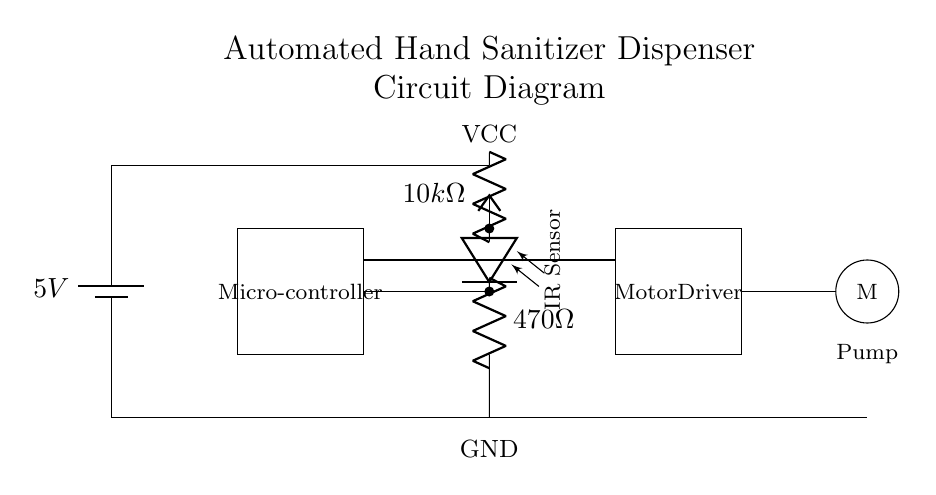What is the voltage supplied in this circuit? The circuit diagram shows a battery marked as 5V connected at the top of the circuit. This indicates that the total voltage supplied to the circuit is 5V.
Answer: 5V What is the purpose of the microcontroller in this circuit? The microcontroller serves as the central control unit that processes inputs from the IR sensor and drives the motor driver to activate the pump, thus dispensing hand sanitizer.
Answer: Control unit What component is used as the sensor for detecting hand presence? The circuit diagram includes an IR sensor, which is specifically labeled and shows a photodiode component that detects infrared light reflecting off a hand, signaling when to dispense sanitizer.
Answer: IR sensor How many resistors are in this circuit? By analyzing the circuit, there are two resistors present: a 10k ohm resistor connected to the IR sensor and a 470 ohm resistor connected in series with the photodiode, making the total count two resistors.
Answer: Two What is the function of the motor driver in this circuit? The motor driver acts as an interface between the microcontroller and the pump motor, allowing the microcontroller to control the power supplied to the motor, thus controlling the operation of the pump for sanitizer dispensing.
Answer: Interface Which component powers the pump? The pump is powered by the output from the motor driver, which controls the current flowing to the pump motor based on signals from the microcontroller.
Answer: Motor driver What is the role of the battery in this circuit? The battery serves as the power source, providing the necessary electrical energy to energize all components in the circuit, including the microcontroller, motor driver, and IR sensor.
Answer: Power source 